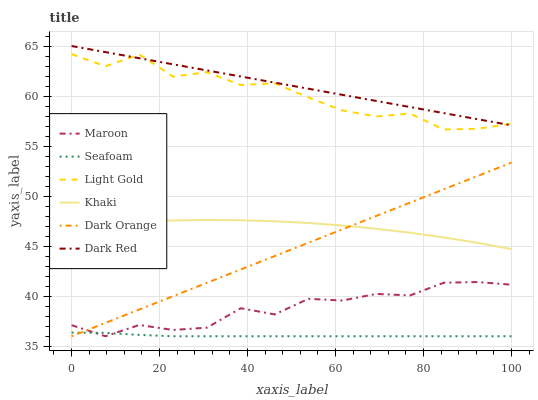Does Khaki have the minimum area under the curve?
Answer yes or no. No. Does Khaki have the maximum area under the curve?
Answer yes or no. No. Is Khaki the smoothest?
Answer yes or no. No. Is Khaki the roughest?
Answer yes or no. No. Does Khaki have the lowest value?
Answer yes or no. No. Does Khaki have the highest value?
Answer yes or no. No. Is Maroon less than Dark Red?
Answer yes or no. Yes. Is Khaki greater than Maroon?
Answer yes or no. Yes. Does Maroon intersect Dark Red?
Answer yes or no. No. 